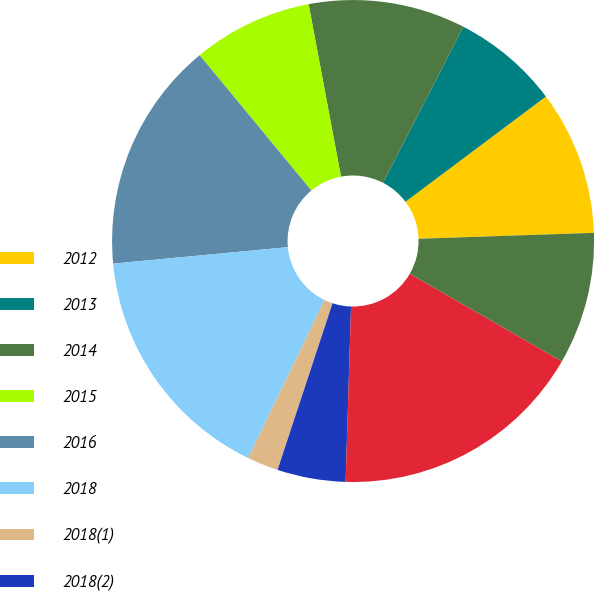<chart> <loc_0><loc_0><loc_500><loc_500><pie_chart><fcel>2012<fcel>2013<fcel>2014<fcel>2015<fcel>2016<fcel>2018<fcel>2018(1)<fcel>2018(2)<fcel>2019<fcel>2020<nl><fcel>9.69%<fcel>7.2%<fcel>10.52%<fcel>8.03%<fcel>15.51%<fcel>16.34%<fcel>2.09%<fcel>4.58%<fcel>17.17%<fcel>8.86%<nl></chart> 